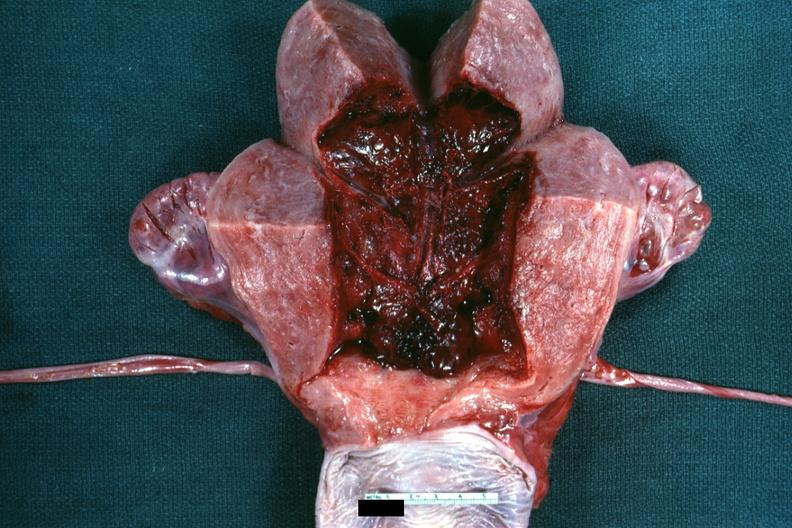s female reproductive present?
Answer the question using a single word or phrase. Yes 